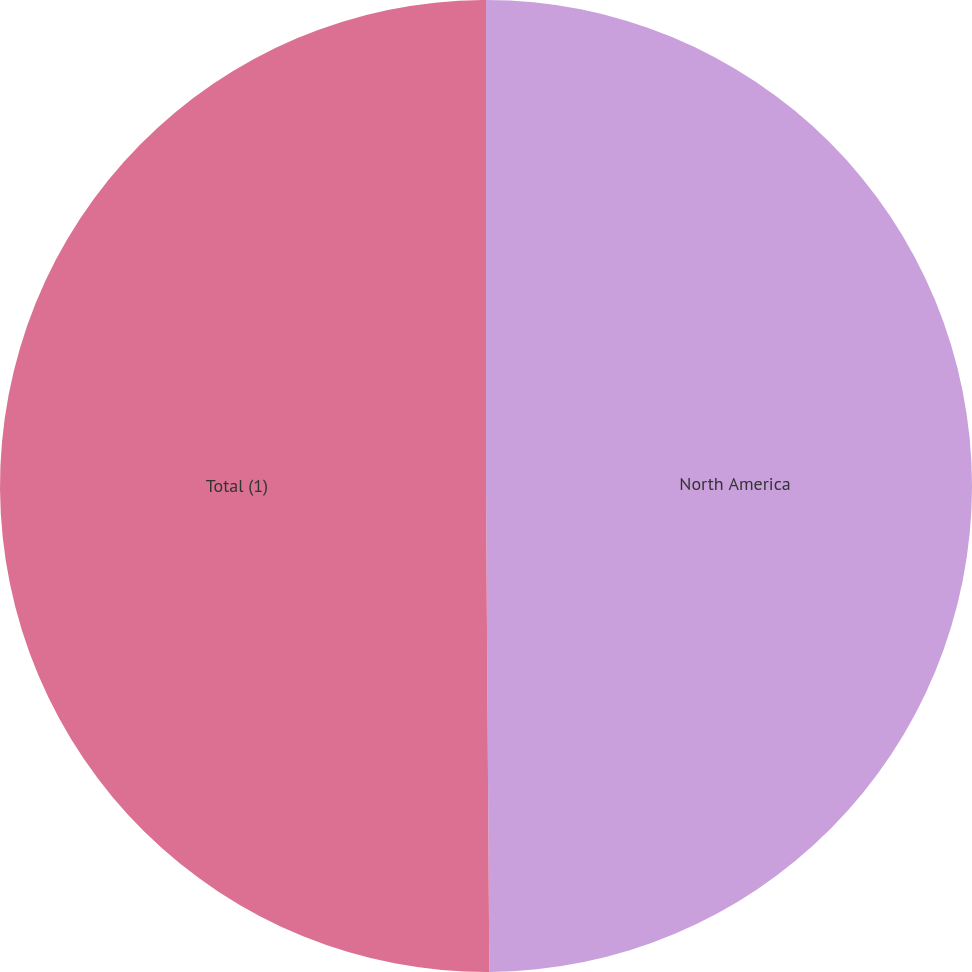Convert chart. <chart><loc_0><loc_0><loc_500><loc_500><pie_chart><fcel>North America<fcel>Total (1)<nl><fcel>49.89%<fcel>50.11%<nl></chart> 